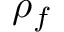Convert formula to latex. <formula><loc_0><loc_0><loc_500><loc_500>\rho _ { f }</formula> 